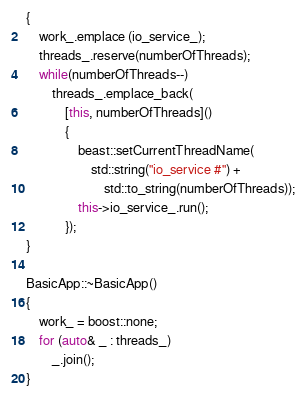<code> <loc_0><loc_0><loc_500><loc_500><_C++_>{
    work_.emplace (io_service_);
    threads_.reserve(numberOfThreads);
    while(numberOfThreads--)
        threads_.emplace_back(
            [this, numberOfThreads]()
            {
                beast::setCurrentThreadName(
                    std::string("io_service #") +
                        std::to_string(numberOfThreads));
                this->io_service_.run();
            });
}

BasicApp::~BasicApp()
{
    work_ = boost::none;
    for (auto& _ : threads_)
        _.join();
}
</code> 